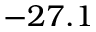Convert formula to latex. <formula><loc_0><loc_0><loc_500><loc_500>- 2 7 . 1</formula> 